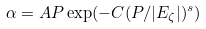<formula> <loc_0><loc_0><loc_500><loc_500>\alpha = A P \exp ( - C ( P / | E _ { \zeta } | ) ^ { s } )</formula> 